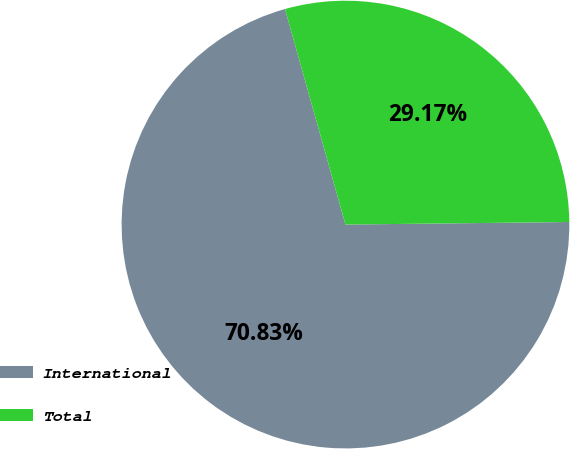<chart> <loc_0><loc_0><loc_500><loc_500><pie_chart><fcel>International<fcel>Total<nl><fcel>70.83%<fcel>29.17%<nl></chart> 